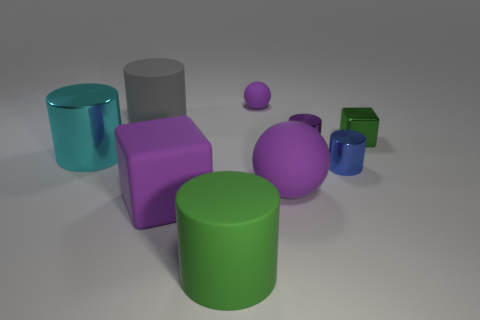What kind of atmosphere or mood does the arrangement of these objects create? The arrangement of objects creates a balanced yet playful atmosphere, with a variety of shapes and colors that might suggest a setting for creative thinking or an abstract art piece. 